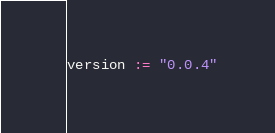Convert code to text. <code><loc_0><loc_0><loc_500><loc_500><_Scala_>version := "0.0.4"
</code> 